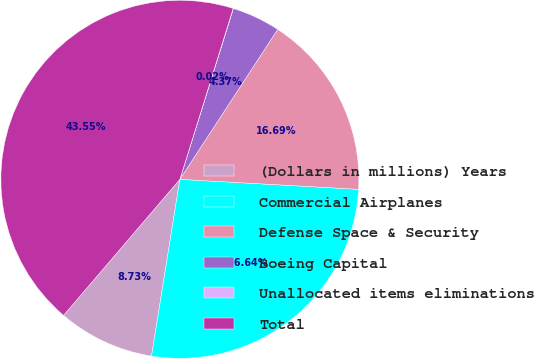Convert chart. <chart><loc_0><loc_0><loc_500><loc_500><pie_chart><fcel>(Dollars in millions) Years<fcel>Commercial Airplanes<fcel>Defense Space & Security<fcel>Boeing Capital<fcel>Unallocated items eliminations<fcel>Total<nl><fcel>8.73%<fcel>26.64%<fcel>16.69%<fcel>4.37%<fcel>0.02%<fcel>43.55%<nl></chart> 